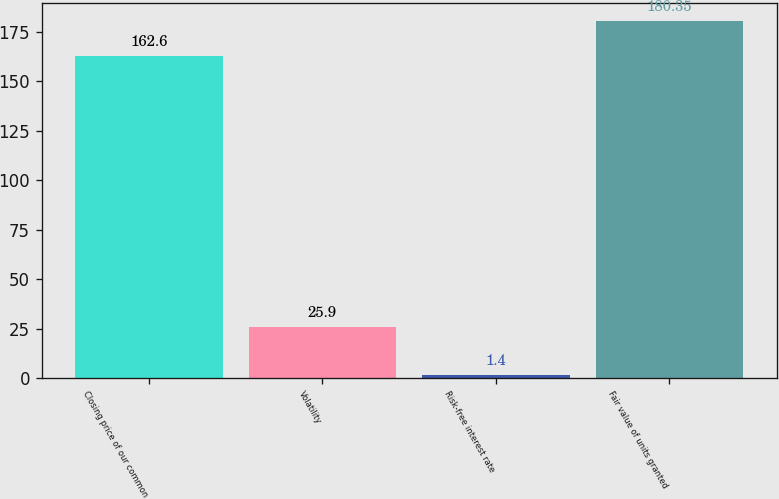<chart> <loc_0><loc_0><loc_500><loc_500><bar_chart><fcel>Closing price of our common<fcel>Volatility<fcel>Risk-free interest rate<fcel>Fair value of units granted<nl><fcel>162.6<fcel>25.9<fcel>1.4<fcel>180.35<nl></chart> 